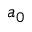Convert formula to latex. <formula><loc_0><loc_0><loc_500><loc_500>a _ { 0 }</formula> 